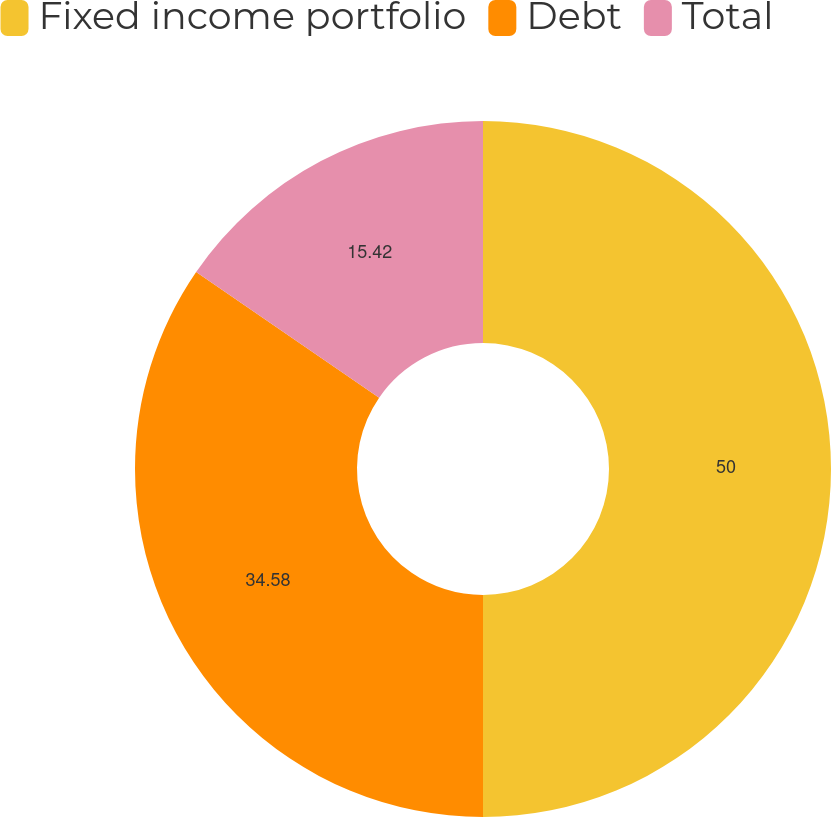Convert chart to OTSL. <chart><loc_0><loc_0><loc_500><loc_500><pie_chart><fcel>Fixed income portfolio<fcel>Debt<fcel>Total<nl><fcel>50.0%<fcel>34.58%<fcel>15.42%<nl></chart> 